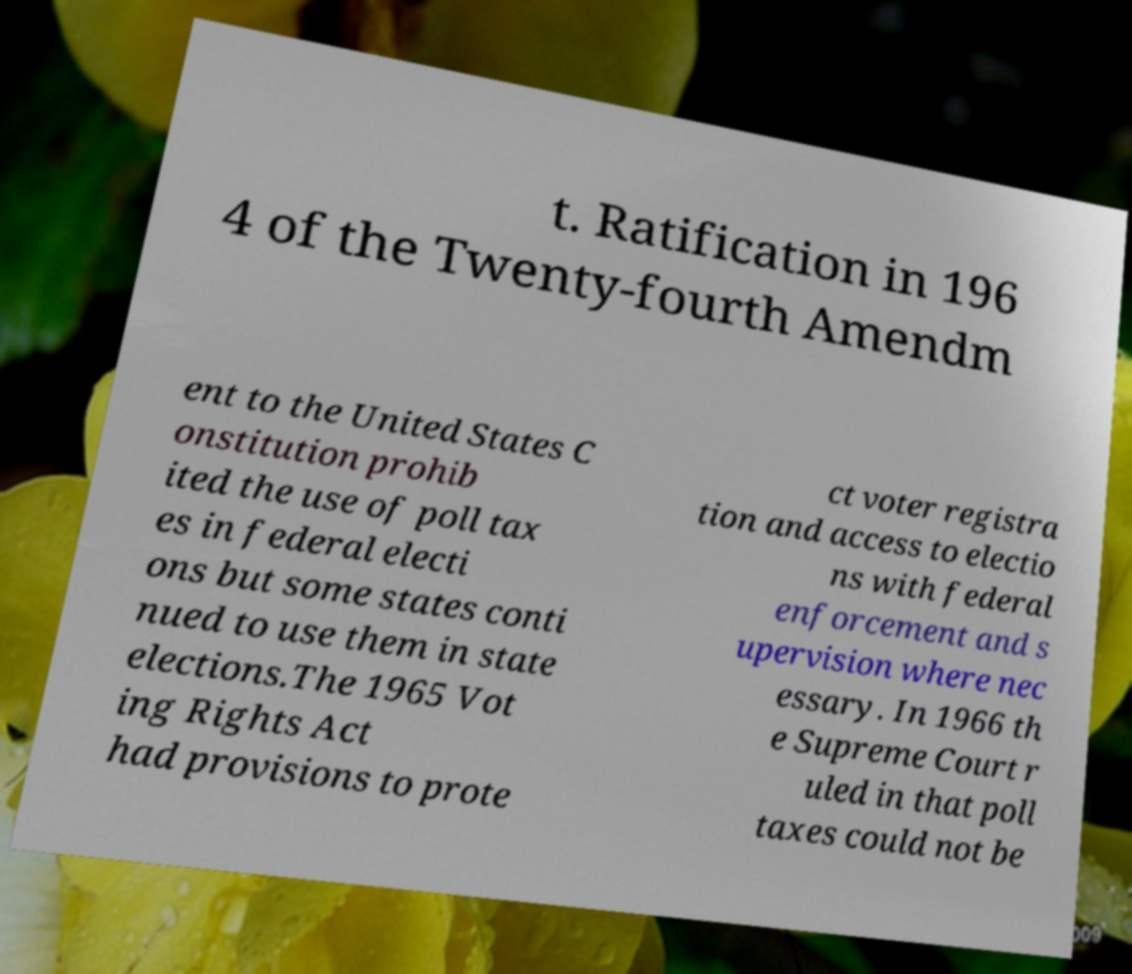There's text embedded in this image that I need extracted. Can you transcribe it verbatim? t. Ratification in 196 4 of the Twenty-fourth Amendm ent to the United States C onstitution prohib ited the use of poll tax es in federal electi ons but some states conti nued to use them in state elections.The 1965 Vot ing Rights Act had provisions to prote ct voter registra tion and access to electio ns with federal enforcement and s upervision where nec essary. In 1966 th e Supreme Court r uled in that poll taxes could not be 